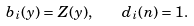<formula> <loc_0><loc_0><loc_500><loc_500>b _ { i } ( y ) = Z ( y ) , \quad d _ { i } ( n ) = 1 .</formula> 